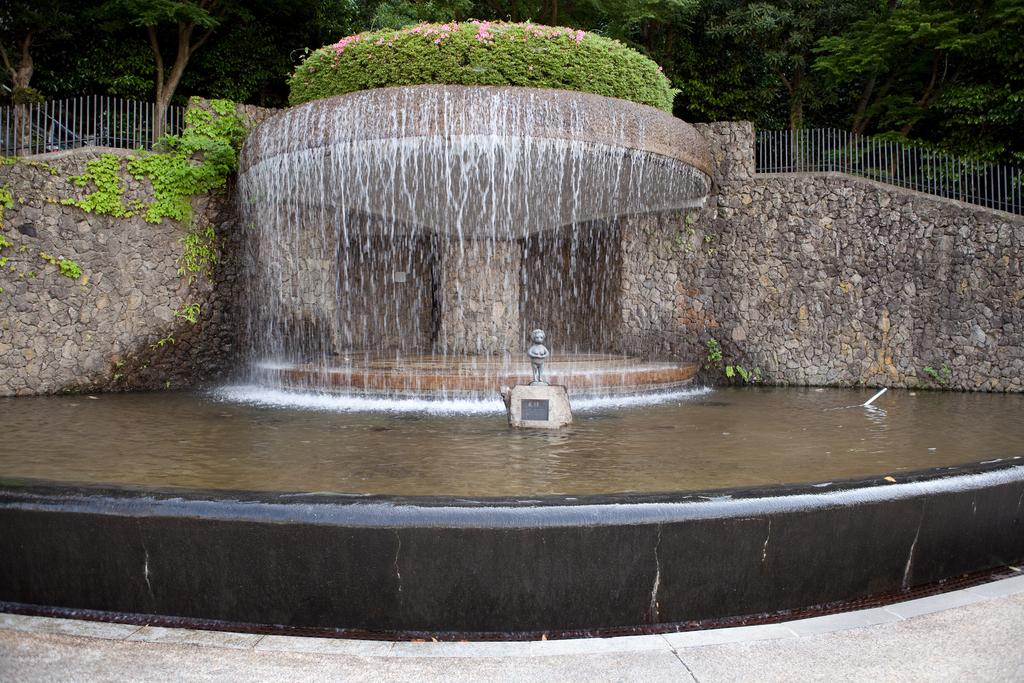What is the main subject of the image? There is a sculpture in the image. What natural features can be seen in the image? There are waterfalls and water visible in the image. What type of man-made structures are present in the image? There is a stone wall and a fence in the image. What type of vegetation is present in the image? Plants and trees are visible in the image. How much sugar is in the waterfall in the image? There is no sugar present in the waterfall in the image. Can you see any bees interacting with the plants in the image? There are no bees visible in the image. 